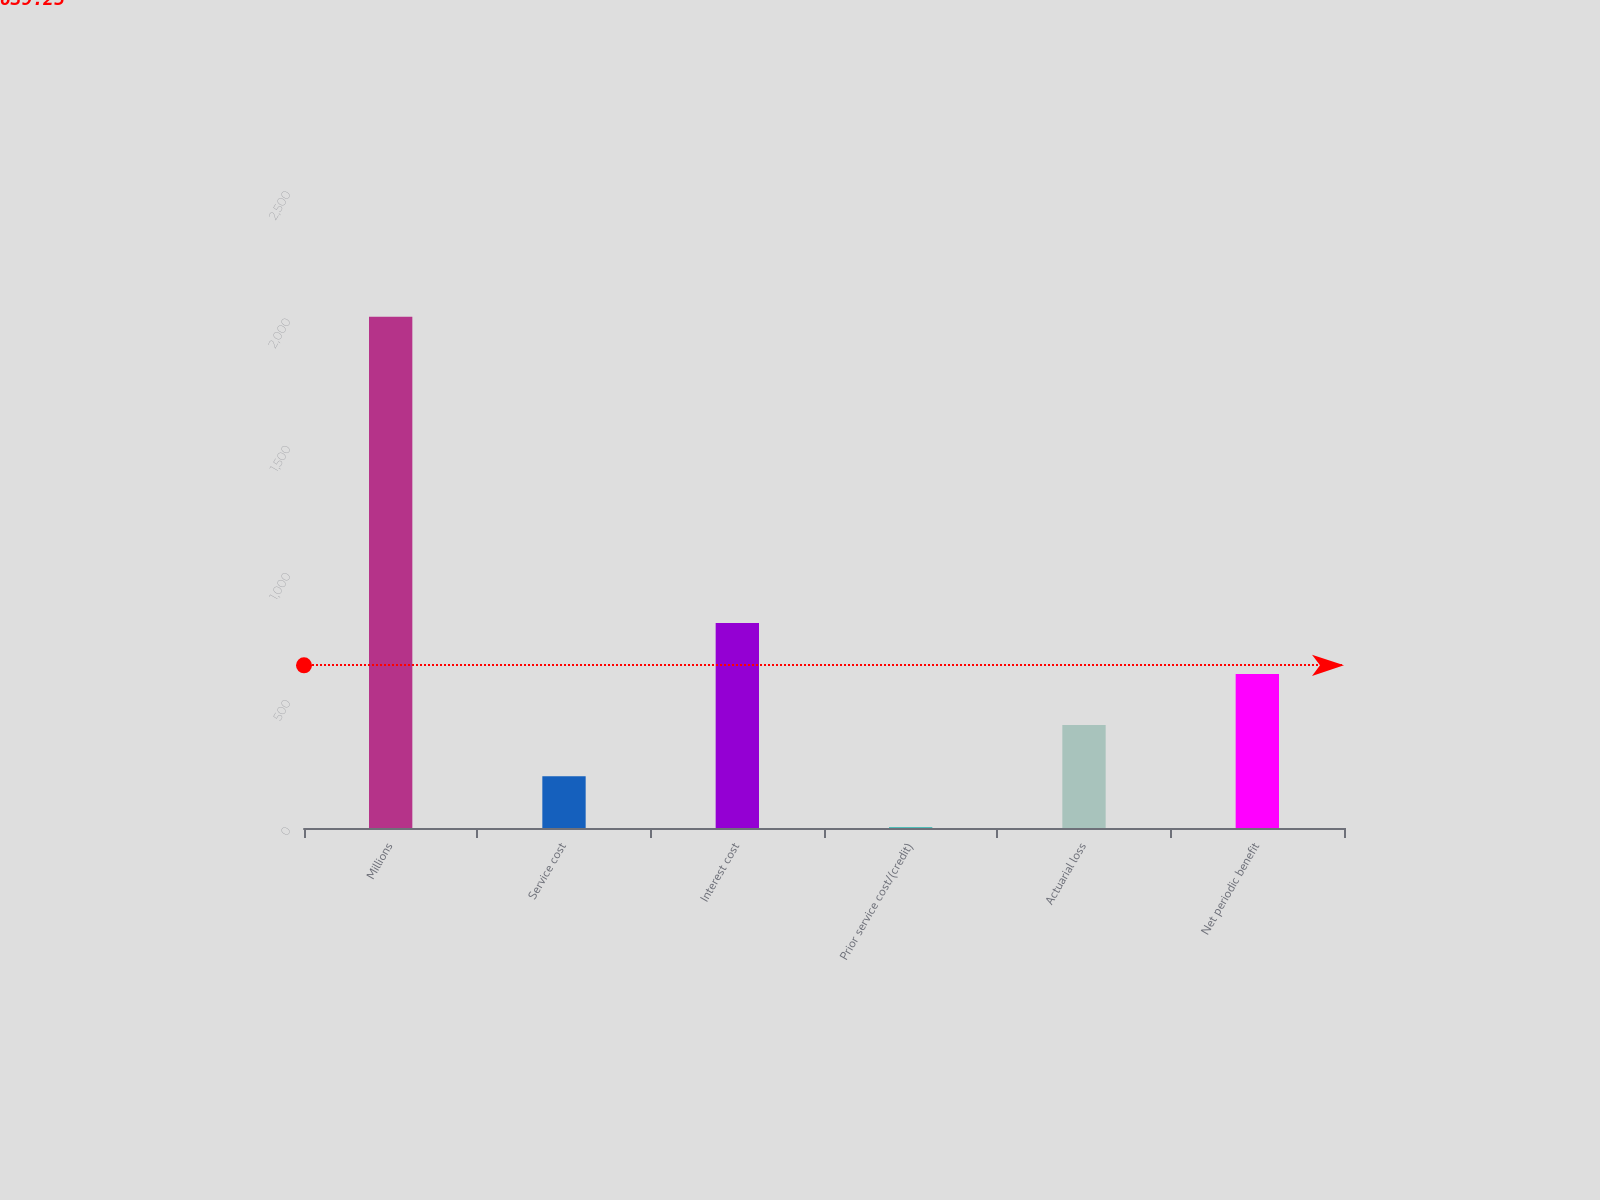Convert chart. <chart><loc_0><loc_0><loc_500><loc_500><bar_chart><fcel>Millions<fcel>Service cost<fcel>Interest cost<fcel>Prior service cost/(credit)<fcel>Actuarial loss<fcel>Net periodic benefit<nl><fcel>2010<fcel>203.7<fcel>805.8<fcel>3<fcel>404.4<fcel>605.1<nl></chart> 